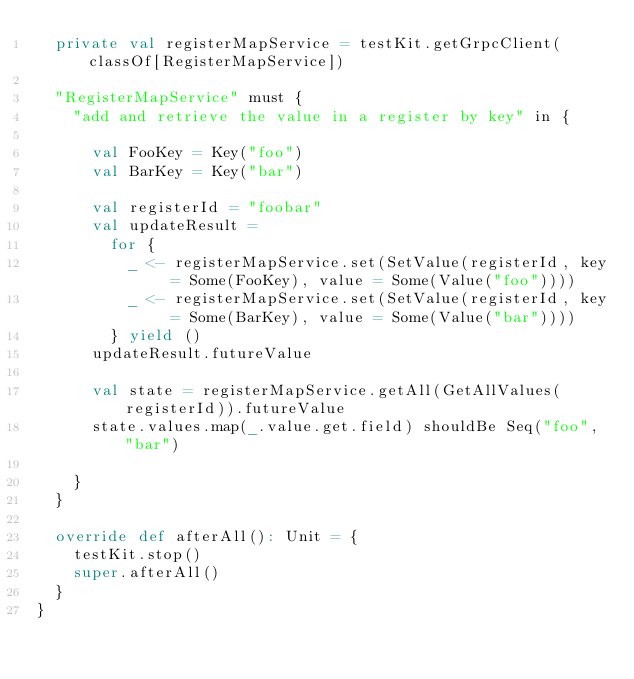Convert code to text. <code><loc_0><loc_0><loc_500><loc_500><_Scala_>  private val registerMapService = testKit.getGrpcClient(classOf[RegisterMapService])

  "RegisterMapService" must {
    "add and retrieve the value in a register by key" in {

      val FooKey = Key("foo")
      val BarKey = Key("bar")

      val registerId = "foobar"
      val updateResult =
        for {
          _ <- registerMapService.set(SetValue(registerId, key = Some(FooKey), value = Some(Value("foo"))))
          _ <- registerMapService.set(SetValue(registerId, key = Some(BarKey), value = Some(Value("bar"))))
        } yield ()
      updateResult.futureValue

      val state = registerMapService.getAll(GetAllValues(registerId)).futureValue
      state.values.map(_.value.get.field) shouldBe Seq("foo", "bar")

    }
  }

  override def afterAll(): Unit = {
    testKit.stop()
    super.afterAll()
  }
}
</code> 